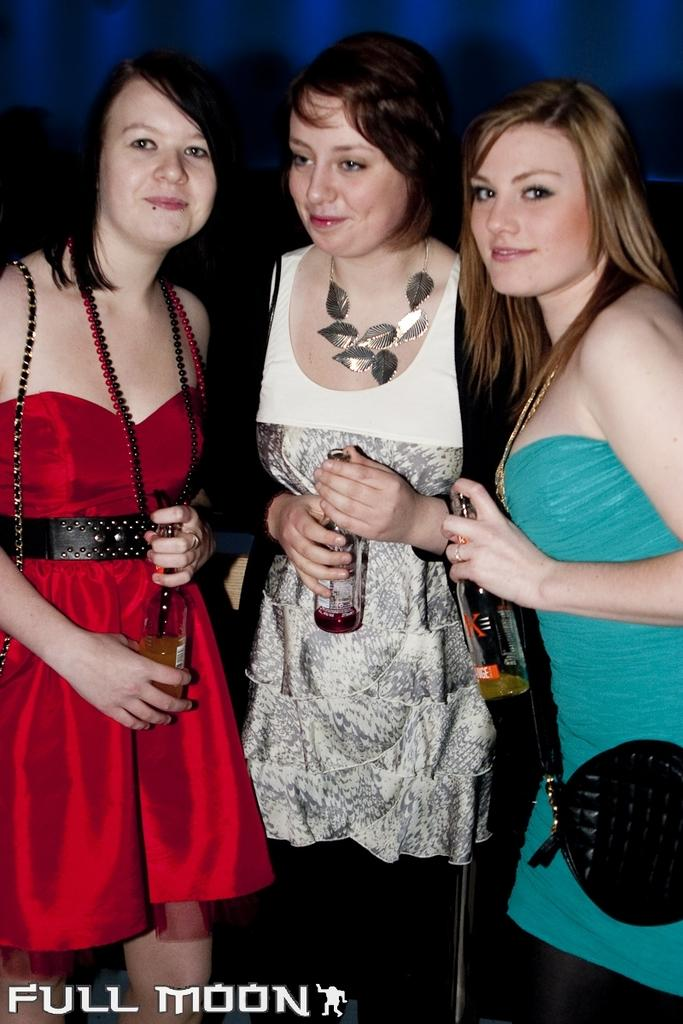How many people are in the image? There are three women in the image. What are the women doing in the image? The women are standing and smiling. What are the women holding in the image? The women are holding bottles with their hands. Can you see any toes in the image? There is no indication of toes being visible in the image. What type of expansion is occurring in the image? There is no expansion occurring in the image; it is a static scene of three women standing and smiling. 